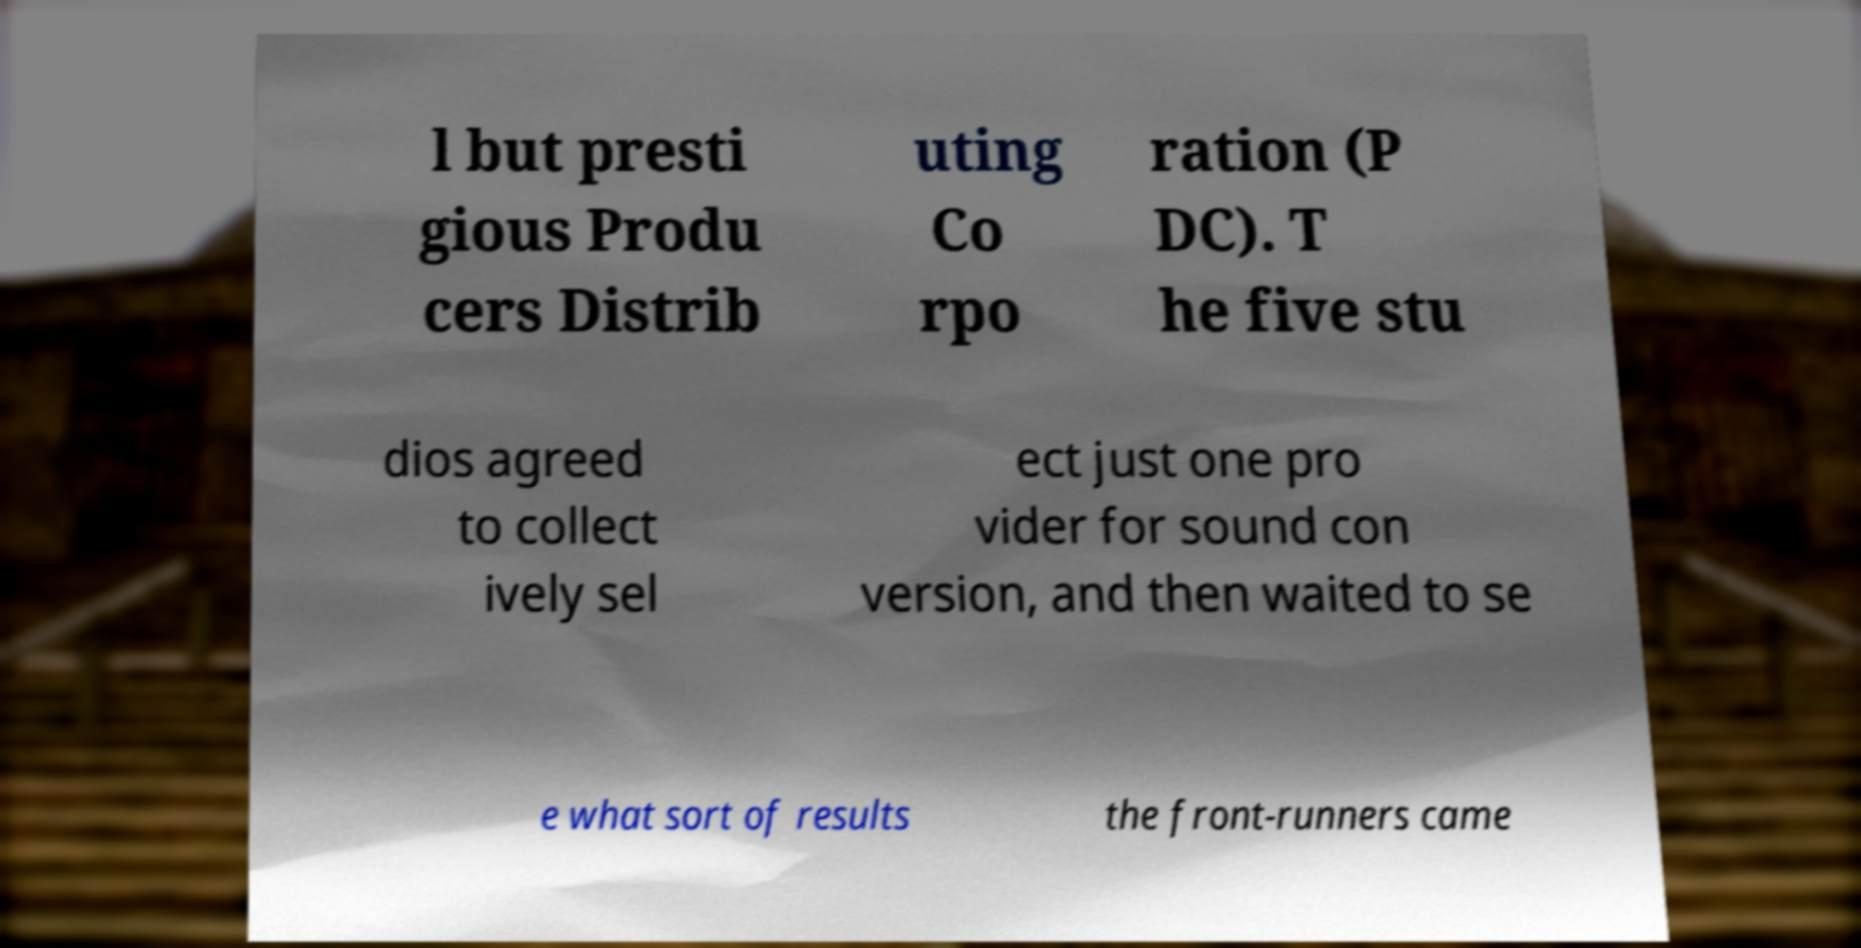Please read and relay the text visible in this image. What does it say? l but presti gious Produ cers Distrib uting Co rpo ration (P DC). T he five stu dios agreed to collect ively sel ect just one pro vider for sound con version, and then waited to se e what sort of results the front-runners came 